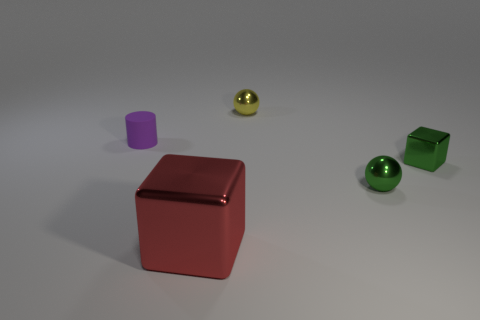This looks like a setup for a physics experiment. What can you infer about the objects' positions? It does resemble a controlled setting. The objects are placed with space between them on a flat surface, which could imply that their positions and distances are important for an experiment, possibly to study motion, collisions, or spatial relationships. 